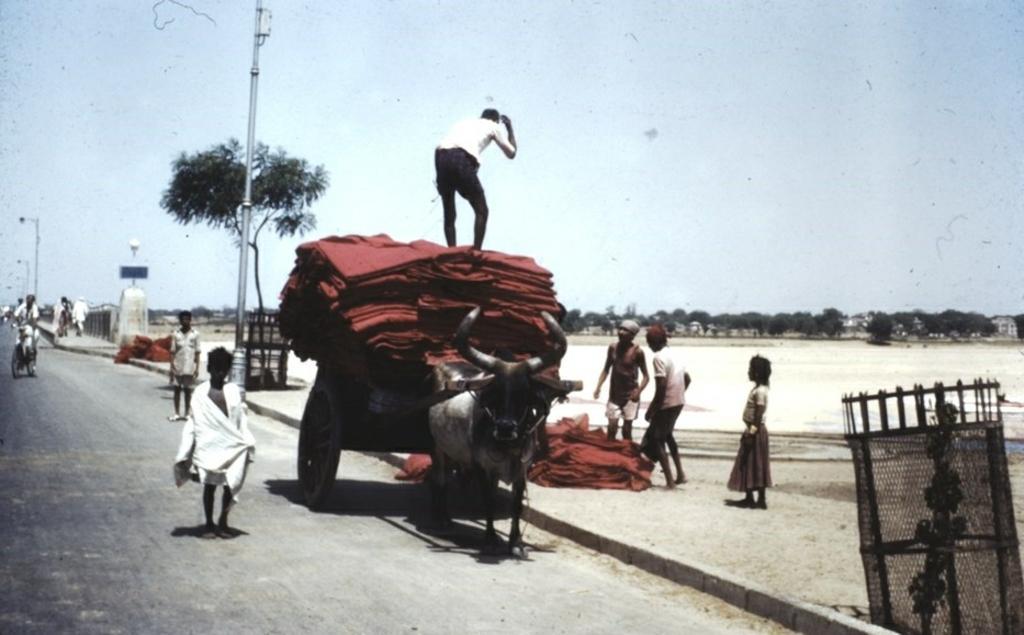Please provide a concise description of this image. In this picture there is a bull and it is carrying a cart and there is a person standing here on the cart and there are some maroon clothes here. In the backdrop there are trees, poles and the sky is clear. 